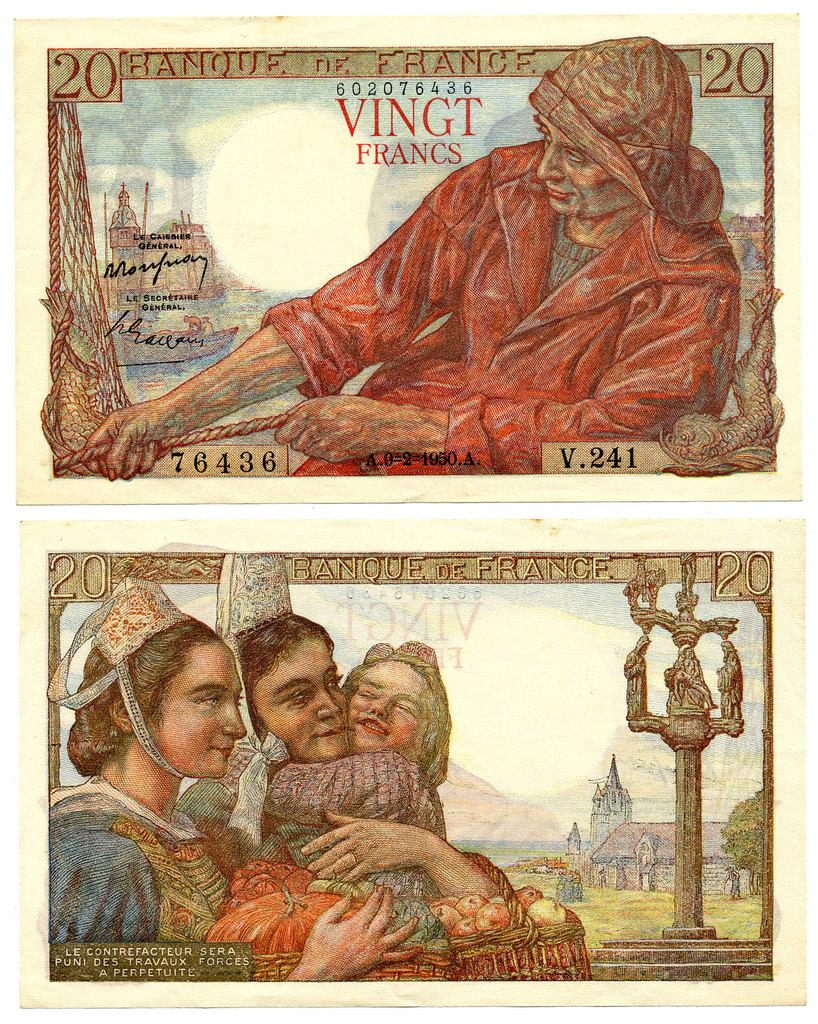What is present in the image in terms of currency? There are two currency notes in the image. What can be seen on the currency notes? The currency notes have images and text on them. How many planes are depicted on the currency notes in the image? There are no planes depicted on the currency notes in the image. What type of rabbits can be seen interacting with the writer on the currency notes? There are no rabbits or writers depicted on the currency notes in the image. 